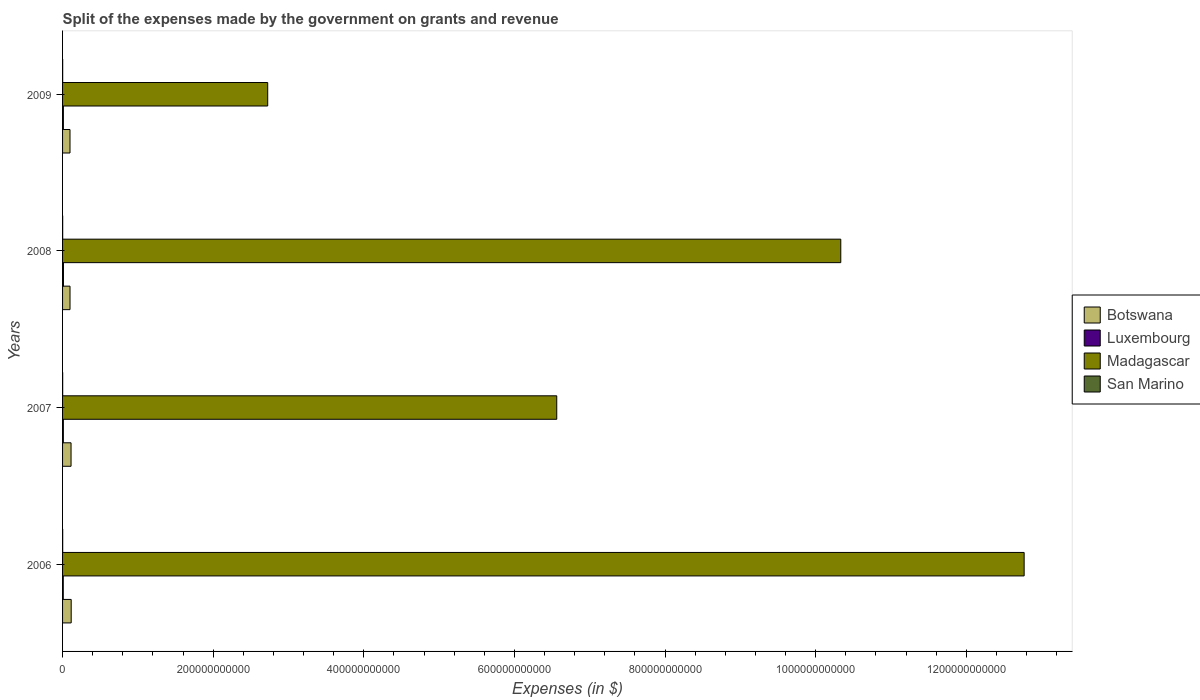How many different coloured bars are there?
Keep it short and to the point. 4. How many bars are there on the 3rd tick from the top?
Provide a succinct answer. 4. How many bars are there on the 3rd tick from the bottom?
Your response must be concise. 4. In how many cases, is the number of bars for a given year not equal to the number of legend labels?
Provide a succinct answer. 0. What is the expenses made by the government on grants and revenue in San Marino in 2009?
Your answer should be very brief. 1.48e+08. Across all years, what is the maximum expenses made by the government on grants and revenue in Madagascar?
Make the answer very short. 1.28e+12. Across all years, what is the minimum expenses made by the government on grants and revenue in San Marino?
Keep it short and to the point. 1.34e+08. What is the total expenses made by the government on grants and revenue in San Marino in the graph?
Make the answer very short. 5.79e+08. What is the difference between the expenses made by the government on grants and revenue in Luxembourg in 2006 and that in 2007?
Offer a terse response. -1.26e+08. What is the difference between the expenses made by the government on grants and revenue in San Marino in 2009 and the expenses made by the government on grants and revenue in Botswana in 2007?
Offer a very short reply. -1.11e+1. What is the average expenses made by the government on grants and revenue in Botswana per year?
Your response must be concise. 1.06e+1. In the year 2007, what is the difference between the expenses made by the government on grants and revenue in Madagascar and expenses made by the government on grants and revenue in Luxembourg?
Offer a terse response. 6.55e+11. What is the ratio of the expenses made by the government on grants and revenue in Madagascar in 2006 to that in 2009?
Your response must be concise. 4.69. Is the expenses made by the government on grants and revenue in Botswana in 2006 less than that in 2008?
Your answer should be compact. No. Is the difference between the expenses made by the government on grants and revenue in Madagascar in 2006 and 2008 greater than the difference between the expenses made by the government on grants and revenue in Luxembourg in 2006 and 2008?
Provide a short and direct response. Yes. What is the difference between the highest and the second highest expenses made by the government on grants and revenue in San Marino?
Your response must be concise. 4.10e+06. What is the difference between the highest and the lowest expenses made by the government on grants and revenue in Botswana?
Give a very brief answer. 1.57e+09. Is it the case that in every year, the sum of the expenses made by the government on grants and revenue in Luxembourg and expenses made by the government on grants and revenue in Madagascar is greater than the sum of expenses made by the government on grants and revenue in Botswana and expenses made by the government on grants and revenue in San Marino?
Your response must be concise. Yes. What does the 3rd bar from the top in 2007 represents?
Offer a very short reply. Luxembourg. What does the 1st bar from the bottom in 2009 represents?
Your answer should be compact. Botswana. How many bars are there?
Provide a short and direct response. 16. What is the difference between two consecutive major ticks on the X-axis?
Give a very brief answer. 2.00e+11. Does the graph contain any zero values?
Your answer should be very brief. No. Where does the legend appear in the graph?
Make the answer very short. Center right. How many legend labels are there?
Provide a short and direct response. 4. How are the legend labels stacked?
Keep it short and to the point. Vertical. What is the title of the graph?
Make the answer very short. Split of the expenses made by the government on grants and revenue. Does "High income: OECD" appear as one of the legend labels in the graph?
Your answer should be compact. No. What is the label or title of the X-axis?
Provide a short and direct response. Expenses (in $). What is the label or title of the Y-axis?
Your response must be concise. Years. What is the Expenses (in $) in Botswana in 2006?
Provide a succinct answer. 1.14e+1. What is the Expenses (in $) in Luxembourg in 2006?
Provide a short and direct response. 9.05e+08. What is the Expenses (in $) in Madagascar in 2006?
Provide a short and direct response. 1.28e+12. What is the Expenses (in $) in San Marino in 2006?
Offer a very short reply. 1.52e+08. What is the Expenses (in $) in Botswana in 2007?
Offer a very short reply. 1.13e+1. What is the Expenses (in $) in Luxembourg in 2007?
Keep it short and to the point. 1.03e+09. What is the Expenses (in $) of Madagascar in 2007?
Your answer should be compact. 6.56e+11. What is the Expenses (in $) of San Marino in 2007?
Make the answer very short. 1.34e+08. What is the Expenses (in $) of Botswana in 2008?
Provide a short and direct response. 9.89e+09. What is the Expenses (in $) of Luxembourg in 2008?
Your response must be concise. 1.19e+09. What is the Expenses (in $) of Madagascar in 2008?
Make the answer very short. 1.03e+12. What is the Expenses (in $) of San Marino in 2008?
Give a very brief answer. 1.45e+08. What is the Expenses (in $) in Botswana in 2009?
Offer a terse response. 9.87e+09. What is the Expenses (in $) in Luxembourg in 2009?
Your answer should be compact. 1.07e+09. What is the Expenses (in $) of Madagascar in 2009?
Your response must be concise. 2.72e+11. What is the Expenses (in $) of San Marino in 2009?
Your answer should be very brief. 1.48e+08. Across all years, what is the maximum Expenses (in $) of Botswana?
Your answer should be very brief. 1.14e+1. Across all years, what is the maximum Expenses (in $) of Luxembourg?
Your answer should be very brief. 1.19e+09. Across all years, what is the maximum Expenses (in $) in Madagascar?
Your answer should be compact. 1.28e+12. Across all years, what is the maximum Expenses (in $) in San Marino?
Your answer should be very brief. 1.52e+08. Across all years, what is the minimum Expenses (in $) of Botswana?
Make the answer very short. 9.87e+09. Across all years, what is the minimum Expenses (in $) in Luxembourg?
Make the answer very short. 9.05e+08. Across all years, what is the minimum Expenses (in $) in Madagascar?
Your response must be concise. 2.72e+11. Across all years, what is the minimum Expenses (in $) in San Marino?
Make the answer very short. 1.34e+08. What is the total Expenses (in $) of Botswana in the graph?
Make the answer very short. 4.25e+1. What is the total Expenses (in $) in Luxembourg in the graph?
Offer a terse response. 4.19e+09. What is the total Expenses (in $) in Madagascar in the graph?
Give a very brief answer. 3.24e+12. What is the total Expenses (in $) of San Marino in the graph?
Keep it short and to the point. 5.79e+08. What is the difference between the Expenses (in $) in Botswana in 2006 and that in 2007?
Provide a succinct answer. 1.78e+08. What is the difference between the Expenses (in $) of Luxembourg in 2006 and that in 2007?
Make the answer very short. -1.26e+08. What is the difference between the Expenses (in $) of Madagascar in 2006 and that in 2007?
Provide a short and direct response. 6.21e+11. What is the difference between the Expenses (in $) of San Marino in 2006 and that in 2007?
Your answer should be very brief. 1.74e+07. What is the difference between the Expenses (in $) in Botswana in 2006 and that in 2008?
Offer a very short reply. 1.55e+09. What is the difference between the Expenses (in $) of Luxembourg in 2006 and that in 2008?
Your answer should be compact. -2.82e+08. What is the difference between the Expenses (in $) in Madagascar in 2006 and that in 2008?
Provide a short and direct response. 2.44e+11. What is the difference between the Expenses (in $) of San Marino in 2006 and that in 2008?
Ensure brevity in your answer.  7.25e+06. What is the difference between the Expenses (in $) in Botswana in 2006 and that in 2009?
Provide a succinct answer. 1.57e+09. What is the difference between the Expenses (in $) in Luxembourg in 2006 and that in 2009?
Provide a succinct answer. -1.65e+08. What is the difference between the Expenses (in $) of Madagascar in 2006 and that in 2009?
Your response must be concise. 1.00e+12. What is the difference between the Expenses (in $) in San Marino in 2006 and that in 2009?
Give a very brief answer. 4.10e+06. What is the difference between the Expenses (in $) of Botswana in 2007 and that in 2008?
Offer a terse response. 1.37e+09. What is the difference between the Expenses (in $) in Luxembourg in 2007 and that in 2008?
Provide a succinct answer. -1.56e+08. What is the difference between the Expenses (in $) in Madagascar in 2007 and that in 2008?
Your response must be concise. -3.77e+11. What is the difference between the Expenses (in $) in San Marino in 2007 and that in 2008?
Offer a terse response. -1.02e+07. What is the difference between the Expenses (in $) of Botswana in 2007 and that in 2009?
Keep it short and to the point. 1.39e+09. What is the difference between the Expenses (in $) of Luxembourg in 2007 and that in 2009?
Offer a terse response. -3.93e+07. What is the difference between the Expenses (in $) in Madagascar in 2007 and that in 2009?
Make the answer very short. 3.84e+11. What is the difference between the Expenses (in $) of San Marino in 2007 and that in 2009?
Your response must be concise. -1.33e+07. What is the difference between the Expenses (in $) of Botswana in 2008 and that in 2009?
Give a very brief answer. 1.95e+07. What is the difference between the Expenses (in $) in Luxembourg in 2008 and that in 2009?
Provide a short and direct response. 1.17e+08. What is the difference between the Expenses (in $) in Madagascar in 2008 and that in 2009?
Your answer should be very brief. 7.61e+11. What is the difference between the Expenses (in $) in San Marino in 2008 and that in 2009?
Your response must be concise. -3.15e+06. What is the difference between the Expenses (in $) of Botswana in 2006 and the Expenses (in $) of Luxembourg in 2007?
Provide a succinct answer. 1.04e+1. What is the difference between the Expenses (in $) of Botswana in 2006 and the Expenses (in $) of Madagascar in 2007?
Your answer should be very brief. -6.45e+11. What is the difference between the Expenses (in $) in Botswana in 2006 and the Expenses (in $) in San Marino in 2007?
Provide a short and direct response. 1.13e+1. What is the difference between the Expenses (in $) in Luxembourg in 2006 and the Expenses (in $) in Madagascar in 2007?
Offer a very short reply. -6.55e+11. What is the difference between the Expenses (in $) of Luxembourg in 2006 and the Expenses (in $) of San Marino in 2007?
Your answer should be compact. 7.71e+08. What is the difference between the Expenses (in $) of Madagascar in 2006 and the Expenses (in $) of San Marino in 2007?
Keep it short and to the point. 1.28e+12. What is the difference between the Expenses (in $) in Botswana in 2006 and the Expenses (in $) in Luxembourg in 2008?
Your answer should be compact. 1.03e+1. What is the difference between the Expenses (in $) in Botswana in 2006 and the Expenses (in $) in Madagascar in 2008?
Your answer should be very brief. -1.02e+12. What is the difference between the Expenses (in $) of Botswana in 2006 and the Expenses (in $) of San Marino in 2008?
Your answer should be compact. 1.13e+1. What is the difference between the Expenses (in $) of Luxembourg in 2006 and the Expenses (in $) of Madagascar in 2008?
Provide a short and direct response. -1.03e+12. What is the difference between the Expenses (in $) of Luxembourg in 2006 and the Expenses (in $) of San Marino in 2008?
Provide a succinct answer. 7.61e+08. What is the difference between the Expenses (in $) of Madagascar in 2006 and the Expenses (in $) of San Marino in 2008?
Your answer should be compact. 1.28e+12. What is the difference between the Expenses (in $) of Botswana in 2006 and the Expenses (in $) of Luxembourg in 2009?
Your response must be concise. 1.04e+1. What is the difference between the Expenses (in $) in Botswana in 2006 and the Expenses (in $) in Madagascar in 2009?
Your response must be concise. -2.61e+11. What is the difference between the Expenses (in $) in Botswana in 2006 and the Expenses (in $) in San Marino in 2009?
Ensure brevity in your answer.  1.13e+1. What is the difference between the Expenses (in $) in Luxembourg in 2006 and the Expenses (in $) in Madagascar in 2009?
Offer a very short reply. -2.71e+11. What is the difference between the Expenses (in $) in Luxembourg in 2006 and the Expenses (in $) in San Marino in 2009?
Make the answer very short. 7.58e+08. What is the difference between the Expenses (in $) in Madagascar in 2006 and the Expenses (in $) in San Marino in 2009?
Offer a terse response. 1.28e+12. What is the difference between the Expenses (in $) of Botswana in 2007 and the Expenses (in $) of Luxembourg in 2008?
Keep it short and to the point. 1.01e+1. What is the difference between the Expenses (in $) of Botswana in 2007 and the Expenses (in $) of Madagascar in 2008?
Keep it short and to the point. -1.02e+12. What is the difference between the Expenses (in $) of Botswana in 2007 and the Expenses (in $) of San Marino in 2008?
Provide a succinct answer. 1.11e+1. What is the difference between the Expenses (in $) of Luxembourg in 2007 and the Expenses (in $) of Madagascar in 2008?
Your response must be concise. -1.03e+12. What is the difference between the Expenses (in $) in Luxembourg in 2007 and the Expenses (in $) in San Marino in 2008?
Provide a short and direct response. 8.87e+08. What is the difference between the Expenses (in $) in Madagascar in 2007 and the Expenses (in $) in San Marino in 2008?
Your response must be concise. 6.56e+11. What is the difference between the Expenses (in $) in Botswana in 2007 and the Expenses (in $) in Luxembourg in 2009?
Give a very brief answer. 1.02e+1. What is the difference between the Expenses (in $) in Botswana in 2007 and the Expenses (in $) in Madagascar in 2009?
Your answer should be very brief. -2.61e+11. What is the difference between the Expenses (in $) of Botswana in 2007 and the Expenses (in $) of San Marino in 2009?
Your response must be concise. 1.11e+1. What is the difference between the Expenses (in $) of Luxembourg in 2007 and the Expenses (in $) of Madagascar in 2009?
Your response must be concise. -2.71e+11. What is the difference between the Expenses (in $) of Luxembourg in 2007 and the Expenses (in $) of San Marino in 2009?
Your response must be concise. 8.83e+08. What is the difference between the Expenses (in $) of Madagascar in 2007 and the Expenses (in $) of San Marino in 2009?
Provide a succinct answer. 6.56e+11. What is the difference between the Expenses (in $) in Botswana in 2008 and the Expenses (in $) in Luxembourg in 2009?
Keep it short and to the point. 8.82e+09. What is the difference between the Expenses (in $) in Botswana in 2008 and the Expenses (in $) in Madagascar in 2009?
Offer a very short reply. -2.63e+11. What is the difference between the Expenses (in $) in Botswana in 2008 and the Expenses (in $) in San Marino in 2009?
Your answer should be compact. 9.75e+09. What is the difference between the Expenses (in $) in Luxembourg in 2008 and the Expenses (in $) in Madagascar in 2009?
Your answer should be compact. -2.71e+11. What is the difference between the Expenses (in $) in Luxembourg in 2008 and the Expenses (in $) in San Marino in 2009?
Your answer should be very brief. 1.04e+09. What is the difference between the Expenses (in $) of Madagascar in 2008 and the Expenses (in $) of San Marino in 2009?
Your response must be concise. 1.03e+12. What is the average Expenses (in $) in Botswana per year?
Your response must be concise. 1.06e+1. What is the average Expenses (in $) of Luxembourg per year?
Provide a succinct answer. 1.05e+09. What is the average Expenses (in $) in Madagascar per year?
Give a very brief answer. 8.10e+11. What is the average Expenses (in $) of San Marino per year?
Make the answer very short. 1.45e+08. In the year 2006, what is the difference between the Expenses (in $) of Botswana and Expenses (in $) of Luxembourg?
Provide a short and direct response. 1.05e+1. In the year 2006, what is the difference between the Expenses (in $) of Botswana and Expenses (in $) of Madagascar?
Ensure brevity in your answer.  -1.27e+12. In the year 2006, what is the difference between the Expenses (in $) of Botswana and Expenses (in $) of San Marino?
Give a very brief answer. 1.13e+1. In the year 2006, what is the difference between the Expenses (in $) of Luxembourg and Expenses (in $) of Madagascar?
Your answer should be very brief. -1.28e+12. In the year 2006, what is the difference between the Expenses (in $) of Luxembourg and Expenses (in $) of San Marino?
Make the answer very short. 7.54e+08. In the year 2006, what is the difference between the Expenses (in $) of Madagascar and Expenses (in $) of San Marino?
Offer a terse response. 1.28e+12. In the year 2007, what is the difference between the Expenses (in $) in Botswana and Expenses (in $) in Luxembourg?
Provide a short and direct response. 1.02e+1. In the year 2007, what is the difference between the Expenses (in $) of Botswana and Expenses (in $) of Madagascar?
Your answer should be very brief. -6.45e+11. In the year 2007, what is the difference between the Expenses (in $) of Botswana and Expenses (in $) of San Marino?
Ensure brevity in your answer.  1.11e+1. In the year 2007, what is the difference between the Expenses (in $) in Luxembourg and Expenses (in $) in Madagascar?
Your answer should be compact. -6.55e+11. In the year 2007, what is the difference between the Expenses (in $) in Luxembourg and Expenses (in $) in San Marino?
Make the answer very short. 8.97e+08. In the year 2007, what is the difference between the Expenses (in $) of Madagascar and Expenses (in $) of San Marino?
Your response must be concise. 6.56e+11. In the year 2008, what is the difference between the Expenses (in $) of Botswana and Expenses (in $) of Luxembourg?
Keep it short and to the point. 8.71e+09. In the year 2008, what is the difference between the Expenses (in $) of Botswana and Expenses (in $) of Madagascar?
Ensure brevity in your answer.  -1.02e+12. In the year 2008, what is the difference between the Expenses (in $) in Botswana and Expenses (in $) in San Marino?
Your response must be concise. 9.75e+09. In the year 2008, what is the difference between the Expenses (in $) of Luxembourg and Expenses (in $) of Madagascar?
Your response must be concise. -1.03e+12. In the year 2008, what is the difference between the Expenses (in $) in Luxembourg and Expenses (in $) in San Marino?
Make the answer very short. 1.04e+09. In the year 2008, what is the difference between the Expenses (in $) in Madagascar and Expenses (in $) in San Marino?
Offer a very short reply. 1.03e+12. In the year 2009, what is the difference between the Expenses (in $) in Botswana and Expenses (in $) in Luxembourg?
Your response must be concise. 8.80e+09. In the year 2009, what is the difference between the Expenses (in $) in Botswana and Expenses (in $) in Madagascar?
Ensure brevity in your answer.  -2.63e+11. In the year 2009, what is the difference between the Expenses (in $) of Botswana and Expenses (in $) of San Marino?
Your answer should be very brief. 9.73e+09. In the year 2009, what is the difference between the Expenses (in $) in Luxembourg and Expenses (in $) in Madagascar?
Make the answer very short. -2.71e+11. In the year 2009, what is the difference between the Expenses (in $) of Luxembourg and Expenses (in $) of San Marino?
Keep it short and to the point. 9.23e+08. In the year 2009, what is the difference between the Expenses (in $) of Madagascar and Expenses (in $) of San Marino?
Make the answer very short. 2.72e+11. What is the ratio of the Expenses (in $) of Botswana in 2006 to that in 2007?
Offer a terse response. 1.02. What is the ratio of the Expenses (in $) of Luxembourg in 2006 to that in 2007?
Provide a succinct answer. 0.88. What is the ratio of the Expenses (in $) in Madagascar in 2006 to that in 2007?
Keep it short and to the point. 1.95. What is the ratio of the Expenses (in $) of San Marino in 2006 to that in 2007?
Keep it short and to the point. 1.13. What is the ratio of the Expenses (in $) of Botswana in 2006 to that in 2008?
Your answer should be compact. 1.16. What is the ratio of the Expenses (in $) in Luxembourg in 2006 to that in 2008?
Ensure brevity in your answer.  0.76. What is the ratio of the Expenses (in $) in Madagascar in 2006 to that in 2008?
Offer a very short reply. 1.24. What is the ratio of the Expenses (in $) in San Marino in 2006 to that in 2008?
Provide a short and direct response. 1.05. What is the ratio of the Expenses (in $) of Botswana in 2006 to that in 2009?
Offer a terse response. 1.16. What is the ratio of the Expenses (in $) of Luxembourg in 2006 to that in 2009?
Keep it short and to the point. 0.85. What is the ratio of the Expenses (in $) in Madagascar in 2006 to that in 2009?
Make the answer very short. 4.69. What is the ratio of the Expenses (in $) of San Marino in 2006 to that in 2009?
Ensure brevity in your answer.  1.03. What is the ratio of the Expenses (in $) of Botswana in 2007 to that in 2008?
Make the answer very short. 1.14. What is the ratio of the Expenses (in $) in Luxembourg in 2007 to that in 2008?
Your answer should be very brief. 0.87. What is the ratio of the Expenses (in $) in Madagascar in 2007 to that in 2008?
Ensure brevity in your answer.  0.64. What is the ratio of the Expenses (in $) in San Marino in 2007 to that in 2008?
Keep it short and to the point. 0.93. What is the ratio of the Expenses (in $) of Botswana in 2007 to that in 2009?
Offer a terse response. 1.14. What is the ratio of the Expenses (in $) in Luxembourg in 2007 to that in 2009?
Give a very brief answer. 0.96. What is the ratio of the Expenses (in $) of Madagascar in 2007 to that in 2009?
Your answer should be compact. 2.41. What is the ratio of the Expenses (in $) of San Marino in 2007 to that in 2009?
Provide a succinct answer. 0.91. What is the ratio of the Expenses (in $) in Luxembourg in 2008 to that in 2009?
Your answer should be compact. 1.11. What is the ratio of the Expenses (in $) of Madagascar in 2008 to that in 2009?
Your answer should be very brief. 3.79. What is the ratio of the Expenses (in $) in San Marino in 2008 to that in 2009?
Provide a succinct answer. 0.98. What is the difference between the highest and the second highest Expenses (in $) of Botswana?
Keep it short and to the point. 1.78e+08. What is the difference between the highest and the second highest Expenses (in $) of Luxembourg?
Offer a very short reply. 1.17e+08. What is the difference between the highest and the second highest Expenses (in $) of Madagascar?
Provide a succinct answer. 2.44e+11. What is the difference between the highest and the second highest Expenses (in $) of San Marino?
Give a very brief answer. 4.10e+06. What is the difference between the highest and the lowest Expenses (in $) of Botswana?
Your answer should be compact. 1.57e+09. What is the difference between the highest and the lowest Expenses (in $) of Luxembourg?
Give a very brief answer. 2.82e+08. What is the difference between the highest and the lowest Expenses (in $) of Madagascar?
Offer a terse response. 1.00e+12. What is the difference between the highest and the lowest Expenses (in $) in San Marino?
Your answer should be compact. 1.74e+07. 